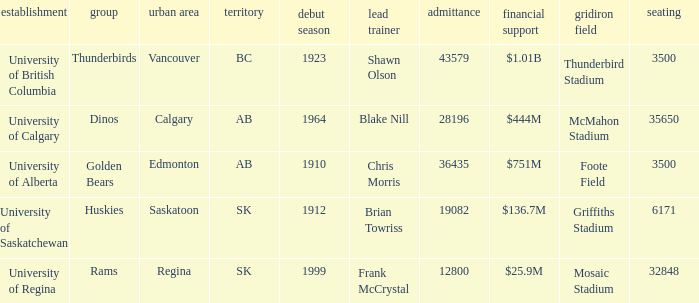What football stadium has a school enrollment of 43579? Thunderbird Stadium. 